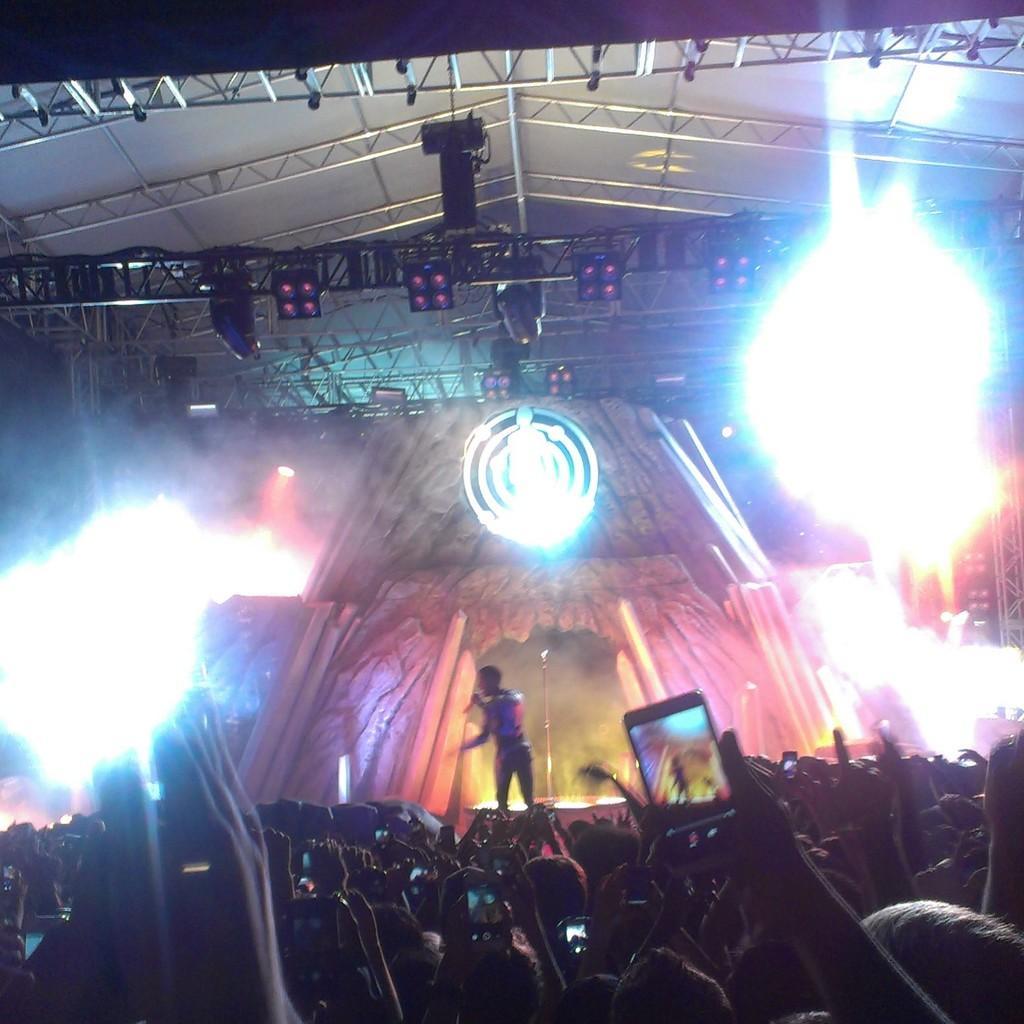Please provide a concise description of this image. In this image I can see number of persons, the stage and a person standing on the stage. I can see few lights and few metal rods to the ceiling of the stage. In the background I can see the dark sky. 